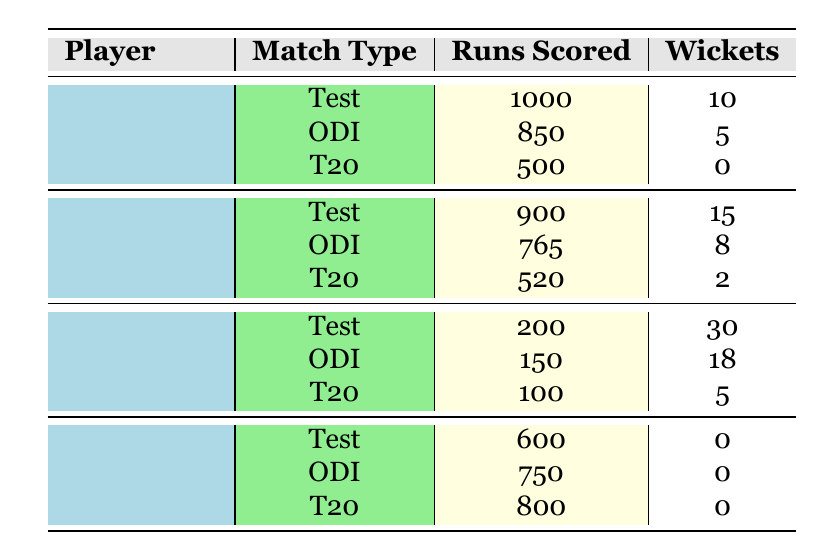What is the total number of wickets taken by Joe Root in 2021? Joe Root took wickets in Test (10), ODI (5), and T20 (0) matches. Adding them gives a total of 10 + 5 + 0 = 15 wickets.
Answer: 15 Which player scored the most runs in ODI matches in 2021? In the ODI matches, Joe Root scored 850 runs, Ben Stokes scored 765 runs, Jofra Archer scored 150 runs, and Jos Buttler scored 750 runs. The highest is Joe Root with 850 runs.
Answer: Joe Root What is the average number of runs scored by Jofra Archer across all match types? Jofra Archer scored 200 runs in Test, 150 runs in ODI, and 100 runs in T20. To find the average, sum them: 200 + 150 + 100 = 450, then divide by the number of matches (3), so 450 / 3 = 150.
Answer: 150 Did any player take more than 20 wickets in 2021? Looking at the wickets taken, Jofra Archer took 30 in Test, 18 in ODI, and 5 in T20, totaling 53 wickets. Since 30 is greater than 20, the statement is true.
Answer: Yes What is the difference in runs scored between Ben Stokes in Test and T20 matches? Ben Stokes scored 900 runs in Test matches and 520 runs in T20 matches. The difference is 900 - 520 = 380.
Answer: 380 